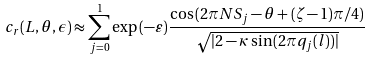Convert formula to latex. <formula><loc_0><loc_0><loc_500><loc_500>c _ { r } ( L , \theta , \epsilon ) \approx \sum ^ { 1 } _ { j = 0 } \exp { ( - \varepsilon ) } \frac { \cos { ( 2 \pi N S _ { j } - \theta + ( \zeta - 1 ) \pi / 4 ) } } { \sqrt { | 2 - \kappa \sin { ( 2 \pi q _ { j } ( l ) } ) | } }</formula> 